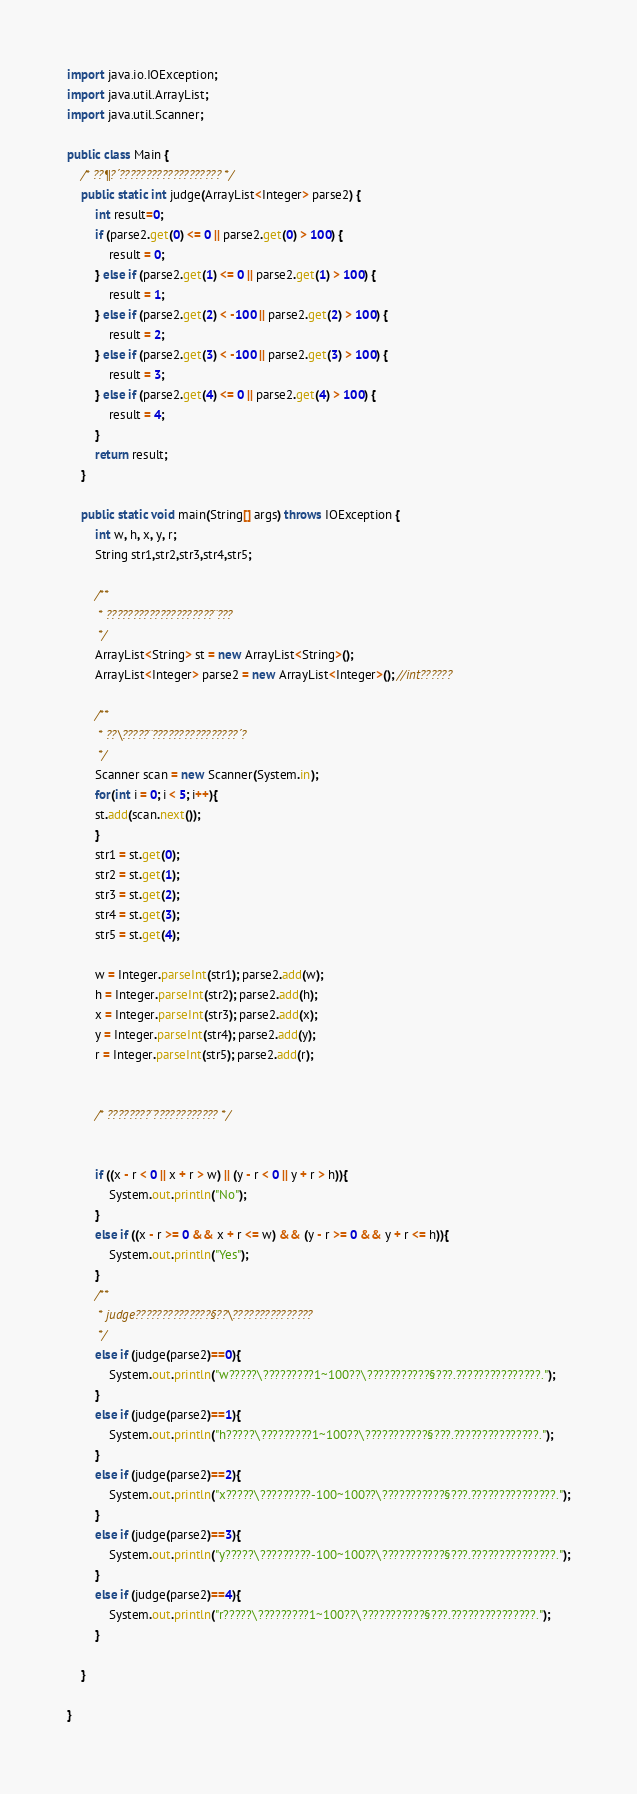<code> <loc_0><loc_0><loc_500><loc_500><_Java_>import java.io.IOException;
import java.util.ArrayList;
import java.util.Scanner;

public class Main {
	/* ??¶?´??????????????????? */
	public static int judge(ArrayList<Integer> parse2) {
		int result=0;
		if (parse2.get(0) <= 0 || parse2.get(0) > 100) {
			result = 0;
		} else if (parse2.get(1) <= 0 || parse2.get(1) > 100) {
			result = 1;
		} else if (parse2.get(2) < -100 || parse2.get(2) > 100) {
			result = 2;
		} else if (parse2.get(3) < -100 || parse2.get(3) > 100) {
			result = 3;
		} else if (parse2.get(4) <= 0 || parse2.get(4) > 100) {
			result = 4;
		}
		return result;
	}

	public static void main(String[] args) throws IOException {
		int w, h, x, y, r;
		String str1,str2,str3,str4,str5;

		/**
		 * ????????????????????¨???
		 */
		ArrayList<String> st = new ArrayList<String>();
		ArrayList<Integer> parse2 = new ArrayList<Integer>(); //int??????

		/**
		 * ??\?????¨????????????????´?
		 */
		Scanner scan = new Scanner(System.in);
		for(int i = 0; i < 5; i++){
		st.add(scan.next());
		}
		str1 = st.get(0);
		str2 = st.get(1);
		str3 = st.get(2);
		str4 = st.get(3);
		str5 = st.get(4);

		w = Integer.parseInt(str1); parse2.add(w);
		h = Integer.parseInt(str2); parse2.add(h);
		x = Integer.parseInt(str3); parse2.add(x);
		y = Integer.parseInt(str4); parse2.add(y);
		r = Integer.parseInt(str5); parse2.add(r);


		/* ????????¨???????????? */


		if ((x - r < 0 || x + r > w) || (y - r < 0 || y + r > h)){
			System.out.println("No");
		}
		else if ((x - r >= 0 && x + r <= w) && (y - r >= 0 && y + r <= h)){
			System.out.println("Yes");
		}
		/**
		 * judge??????????????§??\???????????????
		 */
		else if (judge(parse2)==0){
			System.out.println("w?????\?????????1~100??\???????????§???.???????????????.");
		}
		else if (judge(parse2)==1){
			System.out.println("h?????\?????????1~100??\???????????§???.???????????????.");
		}
		else if (judge(parse2)==2){
			System.out.println("x?????\?????????-100~100??\???????????§???.???????????????.");
		}
		else if (judge(parse2)==3){
			System.out.println("y?????\?????????-100~100??\???????????§???.???????????????.");
		}
		else if (judge(parse2)==4){
			System.out.println("r?????\?????????1~100??\???????????§???.???????????????.");
		}

	}

}</code> 